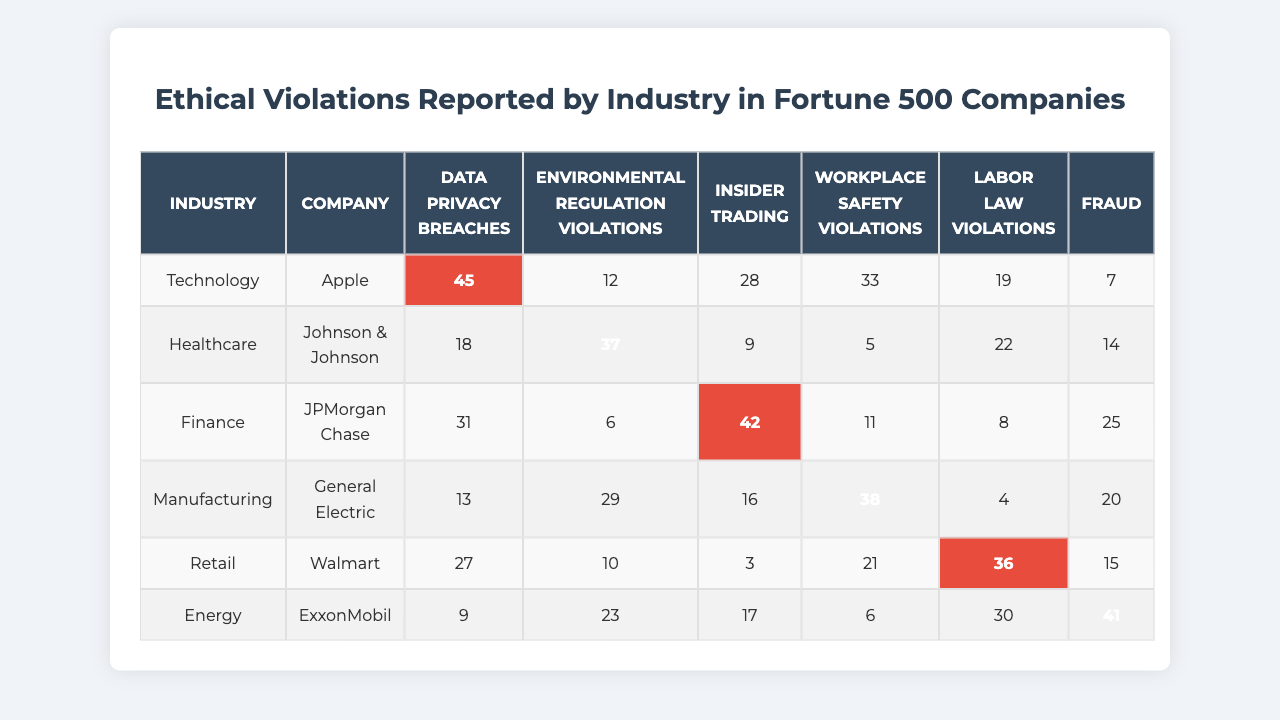What company reported the highest number of labor law violations? By examining the "Labor law violations" column, the highest value is 36, which corresponds to Walmart.
Answer: Walmart Which industry has the lowest total number of ethical violations across all companies? First, we sum the violations for each industry: Technology (45 + 12 + 28 + 33 + 19 + 7 = 144), Healthcare (18 + 37 + 9 + 5 + 22 + 14 = 105), Finance (31 + 6 + 42 + 11 + 8 + 25 = 123), Manufacturing (13 + 29 + 16 + 38 + 4 + 20 = 120), Retail (27 + 10 + 3 + 21 + 36 + 15 = 112), Energy (9 + 23 + 17 + 6 + 30 + 41 = 126). The lowest total is for Healthcare with 105 violations.
Answer: Healthcare Did General Electric report any instances of fraud? Looking at the "Fraud" column under General Electric, the value is 20, indicating that yes, they reported instances of fraud.
Answer: Yes What is the average number of data privacy breaches reported by Technology companies? The Technology companies reported (45 + 12 + 28) = 85 breaches in total across 3 companies. The average is 85/3 ≈ 28.33.
Answer: 28.33 Which company has the most environmental regulation violations? Within the "Environmental regulation violations" column, the highest count is 37, associated with Johnson & Johnson.
Answer: Johnson & Johnson How many more workplace safety violations were reported by General Electric compared to Apple? General Electric reported 38 workplace safety violations, while Apple reported 33. The difference is 38 - 33 = 5.
Answer: 5 What proportion of violations reported by ExxonMobil were related to labor law violations? ExxonMobil reported 41 total violations, with 17 of those related to labor law. The proportion is 17/41 ≈ 0.414 or 41.4%.
Answer: 41.4% Which industry had the highest instance of insider trading violations? The maximum in the "Insider trading" column is 42, reported by JPMorgan Chase in the Finance industry.
Answer: Finance What is the total count of ethical violations across all industries in the Retail sector? Summing the Retail sector's violations gives (27 + 10 + 3 + 21 + 36 + 15) = 112.
Answer: 112 Is it true that the manufacturing companies had more fraud cases than healthcare companies? Manufacturing reported 20 instances of fraud while Healthcare reported 14. Thus, it is true.
Answer: True 